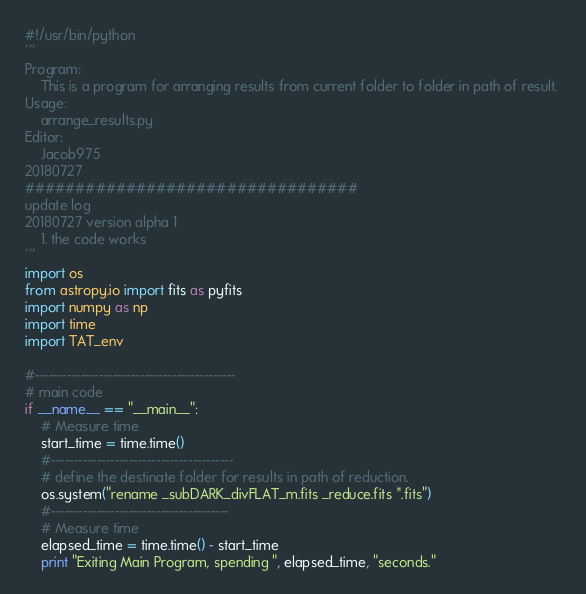<code> <loc_0><loc_0><loc_500><loc_500><_Python_>#!/usr/bin/python
'''
Program:
    This is a program for arranging results from current folder to folder in path of result. 
Usage: 
    arrange_results.py
Editor:
    Jacob975
20180727
#################################
update log
20180727 version alpha 1
    1. the code works
'''
import os 
from astropy.io import fits as pyfits
import numpy as np
import time
import TAT_env

#--------------------------------------------
# main code
if __name__ == "__main__":
    # Measure time
    start_time = time.time()
    #----------------------------------------
    # define the destinate folder for results in path of reduction.
    os.system("rename _subDARK_divFLAT_m.fits _reduce.fits *.fits")
    #---------------------------------------
    # Measure time
    elapsed_time = time.time() - start_time
    print "Exiting Main Program, spending ", elapsed_time, "seconds."
</code> 